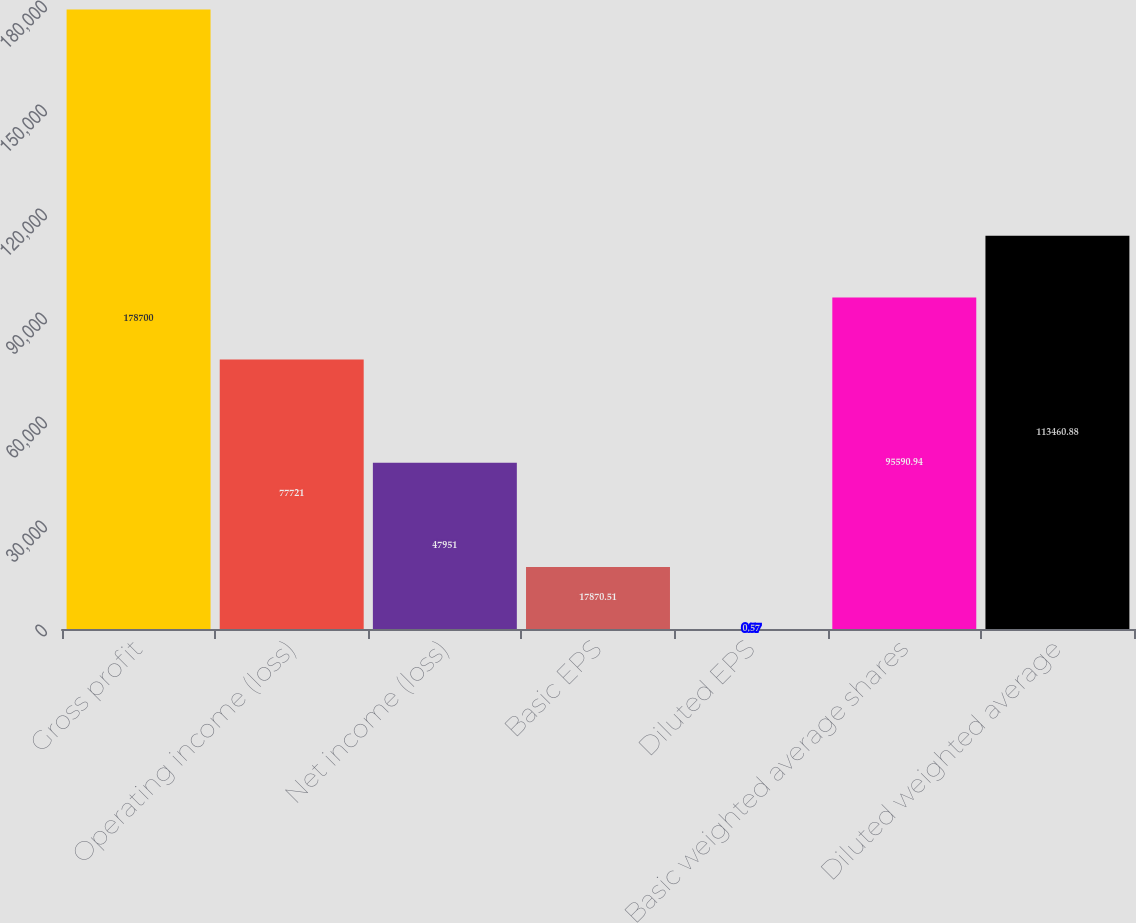Convert chart to OTSL. <chart><loc_0><loc_0><loc_500><loc_500><bar_chart><fcel>Gross profit<fcel>Operating income (loss)<fcel>Net income (loss)<fcel>Basic EPS<fcel>Diluted EPS<fcel>Basic weighted average shares<fcel>Diluted weighted average<nl><fcel>178700<fcel>77721<fcel>47951<fcel>17870.5<fcel>0.57<fcel>95590.9<fcel>113461<nl></chart> 